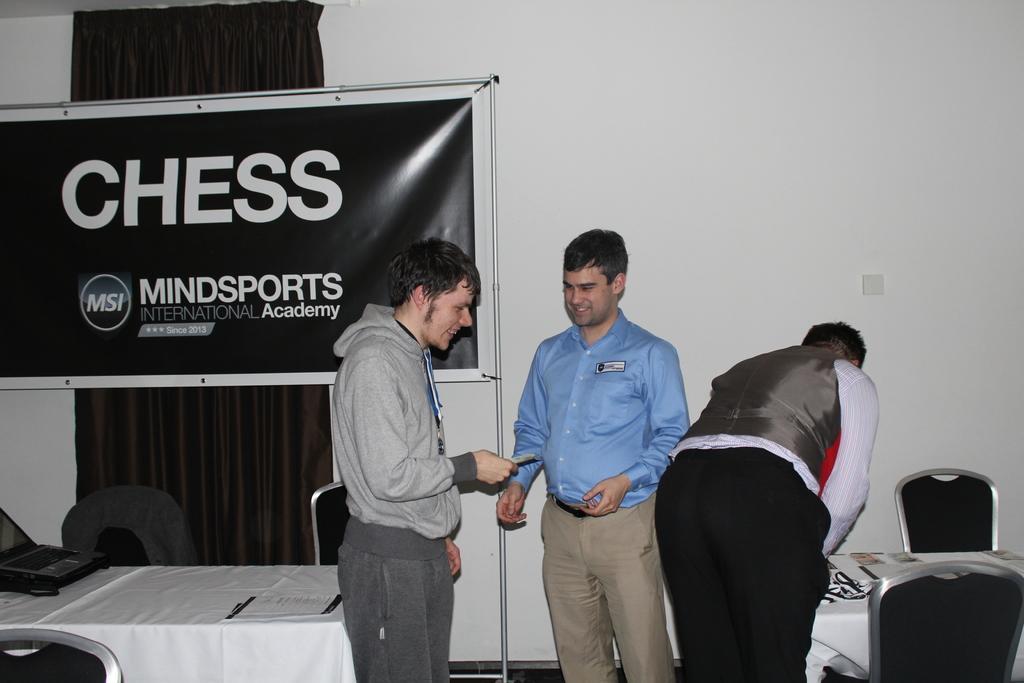How would you summarize this image in a sentence or two? In this image I see 3 men standing and in which 2 of them are smiling and there are few chairs and 2 tables. In the background I see a banner and the wall. 